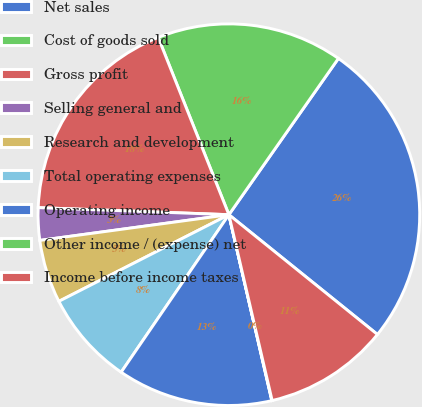Convert chart. <chart><loc_0><loc_0><loc_500><loc_500><pie_chart><fcel>Net sales<fcel>Cost of goods sold<fcel>Gross profit<fcel>Selling general and<fcel>Research and development<fcel>Total operating expenses<fcel>Operating income<fcel>Other income / (expense) net<fcel>Income before income taxes<nl><fcel>26.07%<fcel>15.77%<fcel>18.37%<fcel>2.74%<fcel>5.35%<fcel>7.95%<fcel>13.16%<fcel>0.03%<fcel>10.56%<nl></chart> 